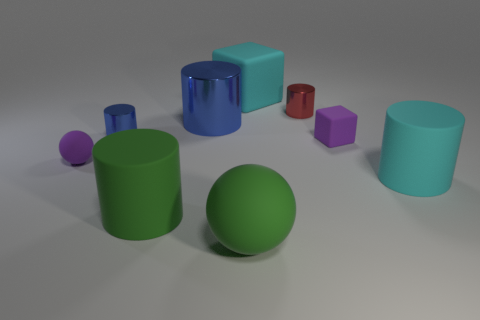Subtract all small blue metallic cylinders. How many cylinders are left? 4 Subtract all blue blocks. How many blue cylinders are left? 2 Subtract all green cylinders. How many cylinders are left? 4 Subtract 4 cylinders. How many cylinders are left? 1 Add 1 brown things. How many objects exist? 10 Subtract all small green metal blocks. Subtract all tiny purple balls. How many objects are left? 8 Add 8 tiny blue shiny things. How many tiny blue shiny things are left? 9 Add 8 small cyan cylinders. How many small cyan cylinders exist? 8 Subtract 0 yellow blocks. How many objects are left? 9 Subtract all blocks. How many objects are left? 7 